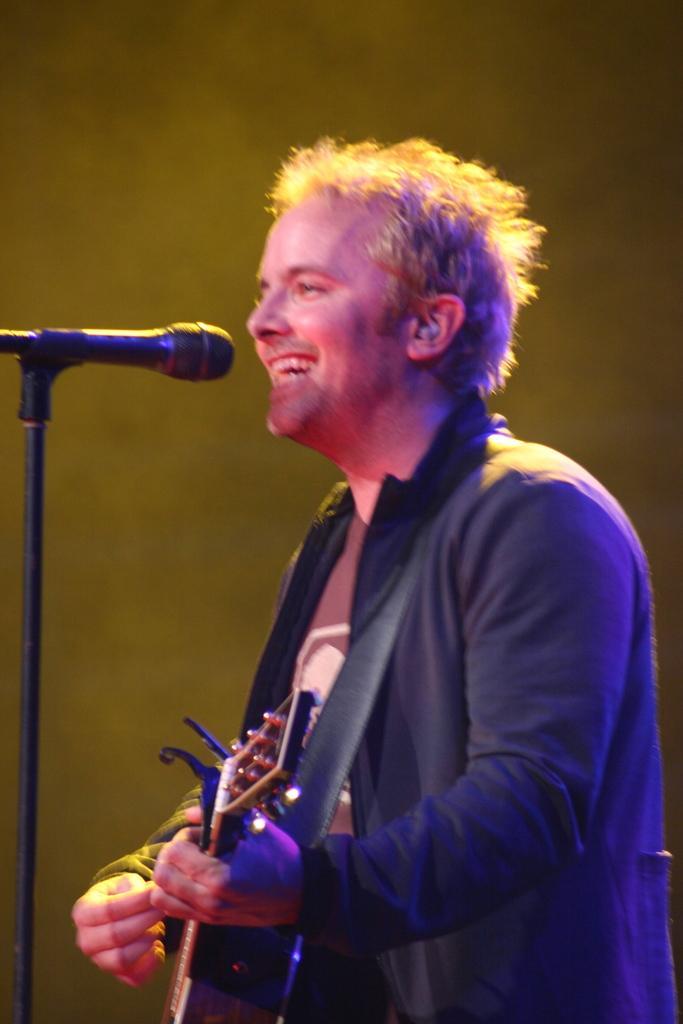How would you summarize this image in a sentence or two? There is a person standing in the center. He is playing a guitar and he is singing on a microphone and there is a pretty smile on his face. 